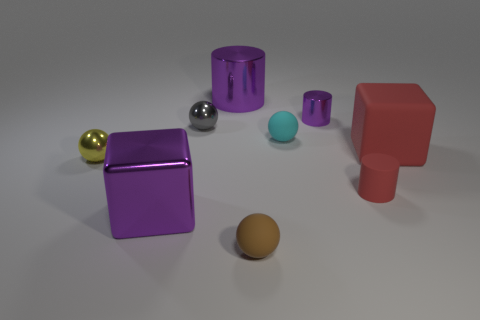What is the shape of the small matte object on the left side of the cyan thing?
Your response must be concise. Sphere. Is there a purple cylinder of the same size as the yellow metal object?
Your answer should be very brief. Yes. What is the material of the purple cylinder that is the same size as the cyan rubber object?
Keep it short and to the point. Metal. There is a purple thing that is on the right side of the cyan thing; what size is it?
Provide a succinct answer. Small. What size is the matte block?
Ensure brevity in your answer.  Large. Does the cyan ball have the same size as the red block right of the gray metal ball?
Provide a short and direct response. No. What color is the small sphere that is to the right of the small thing in front of the metallic block?
Give a very brief answer. Cyan. Are there an equal number of purple metal cylinders in front of the matte cube and big purple things behind the purple block?
Give a very brief answer. No. Does the large block on the right side of the tiny cyan ball have the same material as the yellow thing?
Offer a terse response. No. There is a thing that is left of the big cylinder and in front of the tiny yellow object; what color is it?
Offer a terse response. Purple. 